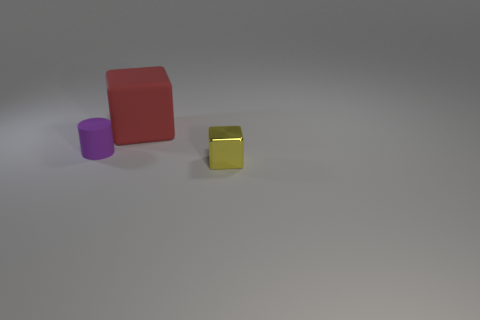Are there any patterns or textures on the objects? The objects appear to have smooth surfaces without any discernible patterns or textures. What might be the purpose of this arrangement of objects? This arrangement of objects could be part of a visual composition exercise, exploring color contrast, object placement, or used for light and shadow studies. 